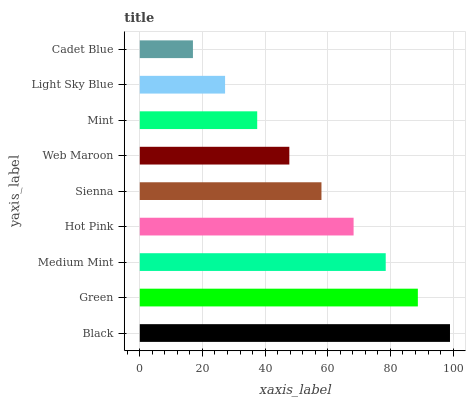Is Cadet Blue the minimum?
Answer yes or no. Yes. Is Black the maximum?
Answer yes or no. Yes. Is Green the minimum?
Answer yes or no. No. Is Green the maximum?
Answer yes or no. No. Is Black greater than Green?
Answer yes or no. Yes. Is Green less than Black?
Answer yes or no. Yes. Is Green greater than Black?
Answer yes or no. No. Is Black less than Green?
Answer yes or no. No. Is Sienna the high median?
Answer yes or no. Yes. Is Sienna the low median?
Answer yes or no. Yes. Is Cadet Blue the high median?
Answer yes or no. No. Is Cadet Blue the low median?
Answer yes or no. No. 